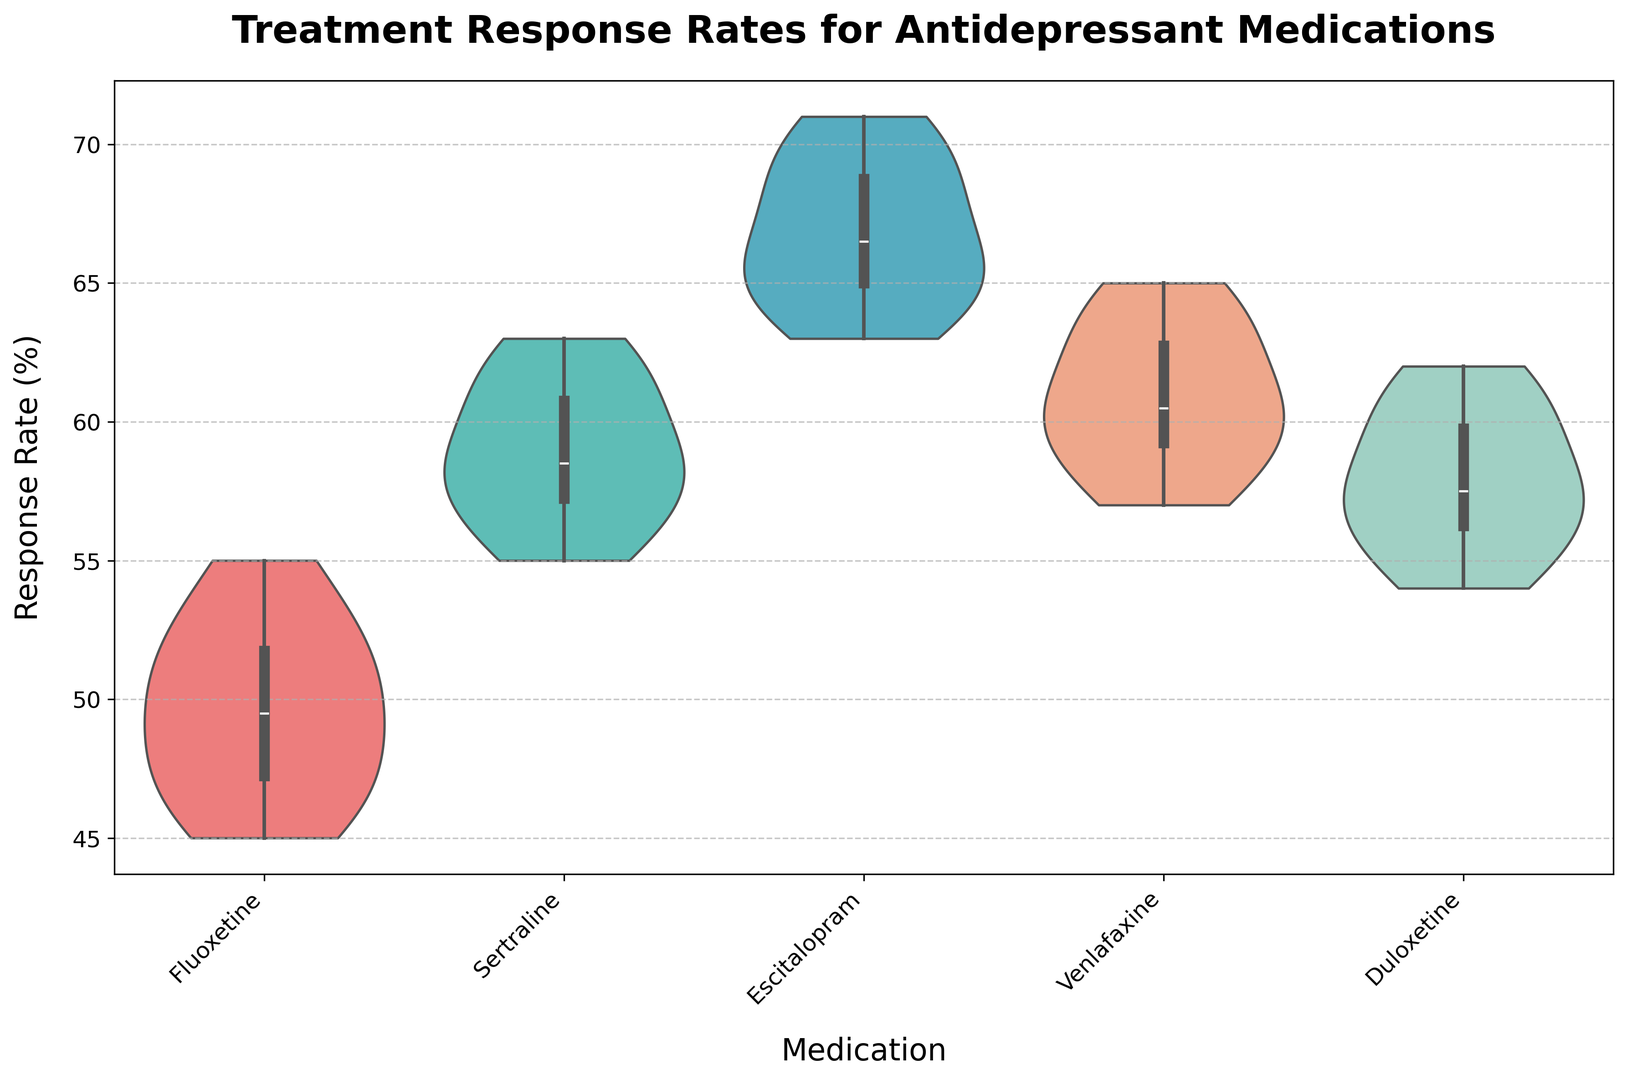Which medication has the highest median response rate? The median is the middle value of a dataset sorted in ascending order. For Escitalopram, the middle value of its sorted response rates is 65. The other medications have lower median values.
Answer: Escitalopram Which medication shows the most variation in response rates? Variation can be visually assessed by the width of the violins. Escitalopram’s violin is wider, especially in the middle, suggesting more variability around the median.
Answer: Escitalopram Is Venlafaxine’s response rate range higher or lower than Fluoxetine’s? The range of a dataset refers to the difference between its highest and lowest values. Venlafaxine has a range of (65-57) = 8, and Fluoxetine has a range of (55-45) = 10. Thus, the range for Venlafaxine is lower than Fluoxetine’s.
Answer: Lower How do the spread and skewness of Duloxetine's response rates compare to those of Sertraline? Spread refers to the overall width of the violin plot. Skewness can be assessed by visual symmetry. Duloxetine’s plot is narrower in spread compared to Sertraline’s, and both appear relatively symmetric, indicating low skewness.
Answer: Less spread, symmetric Which medications have a response rate that exceeds 60% for most subjects? If a majority of a medication's data points exceed 60%, this indicates a higher overall response rate. Sertraline, Escitalopram, and Venlafaxine all have major portions exceeding the 60% mark.
Answer: Sertraline, Escitalopram, Venlafaxine 